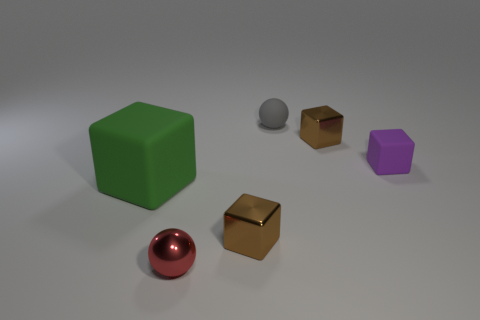Is the green object the same shape as the small purple object? Yes, the green object and the small purple object both appear to be cubes, sharing the same six-sided square-shape geometry despite the difference in their sizes and colors. 